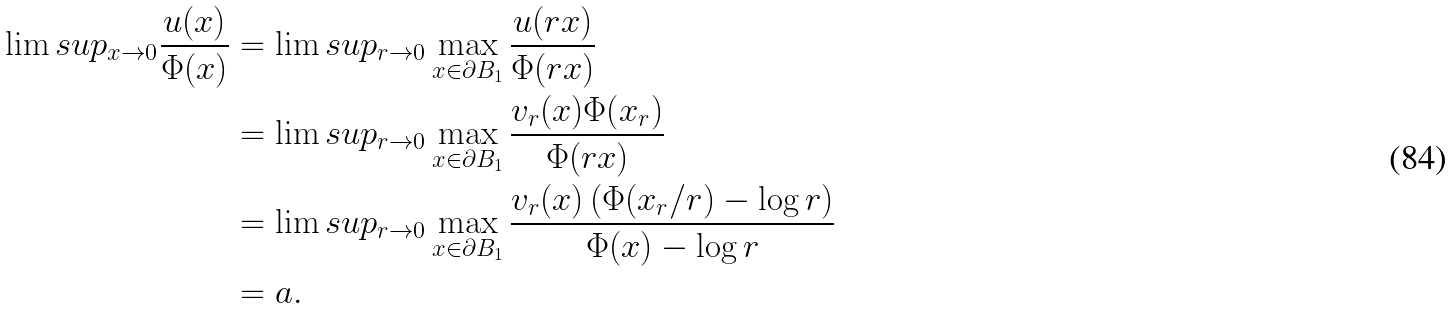<formula> <loc_0><loc_0><loc_500><loc_500>\lim s u p _ { x \to 0 } \frac { u ( x ) } { \Phi ( x ) } & = \lim s u p _ { r \to 0 } \max _ { x \in \partial B _ { 1 } } \frac { u ( r x ) } { \Phi ( r x ) } \\ & = \lim s u p _ { r \to 0 } \max _ { x \in \partial B _ { 1 } } \frac { v _ { r } ( x ) \Phi ( x _ { r } ) } { \Phi ( r x ) } \\ & = \lim s u p _ { r \to 0 } \max _ { x \in \partial B _ { 1 } } \frac { v _ { r } ( x ) \left ( \Phi ( x _ { r } / r ) - \log r \right ) } { \Phi ( x ) - \log r } \\ & = a .</formula> 